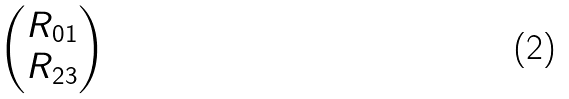Convert formula to latex. <formula><loc_0><loc_0><loc_500><loc_500>\begin{pmatrix} R _ { 0 1 } \\ R _ { 2 3 } \\ \end{pmatrix}</formula> 